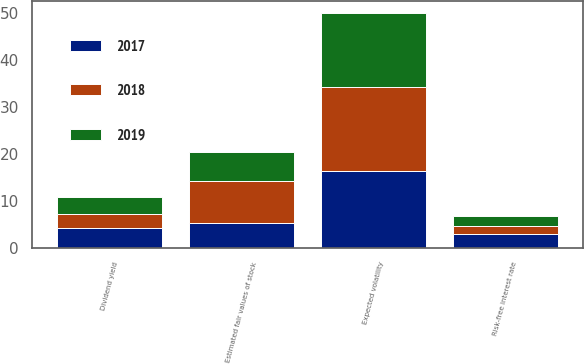Convert chart to OTSL. <chart><loc_0><loc_0><loc_500><loc_500><stacked_bar_chart><ecel><fcel>Estimated fair values of stock<fcel>Risk-free interest rate<fcel>Expected volatility<fcel>Dividend yield<nl><fcel>2017<fcel>5.35<fcel>2.9<fcel>16.3<fcel>4.3<nl><fcel>2019<fcel>6.18<fcel>2.2<fcel>15.8<fcel>3.6<nl><fcel>2018<fcel>8.8<fcel>1.7<fcel>17.8<fcel>2.9<nl></chart> 